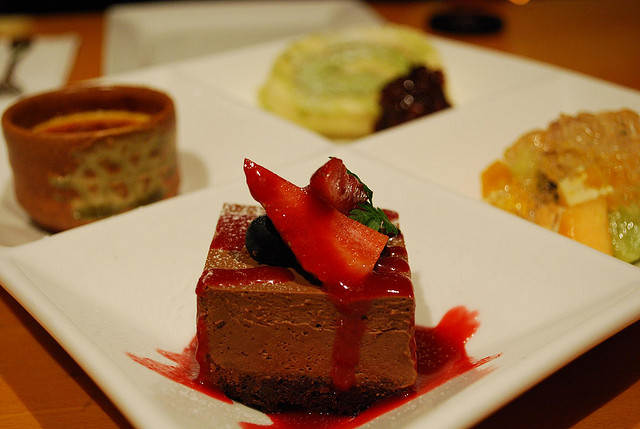<image>Why is this particular dessert located in the foreground? I am not sure why this particular dessert is located in the foreground. It could be due to its attractive appearance or because it is the focus of the picture. Why is this particular dessert located in the foreground? I am not sure why this particular dessert is located in the foreground. It could be because it is the best looking, most attractive, or it looks delicious. 